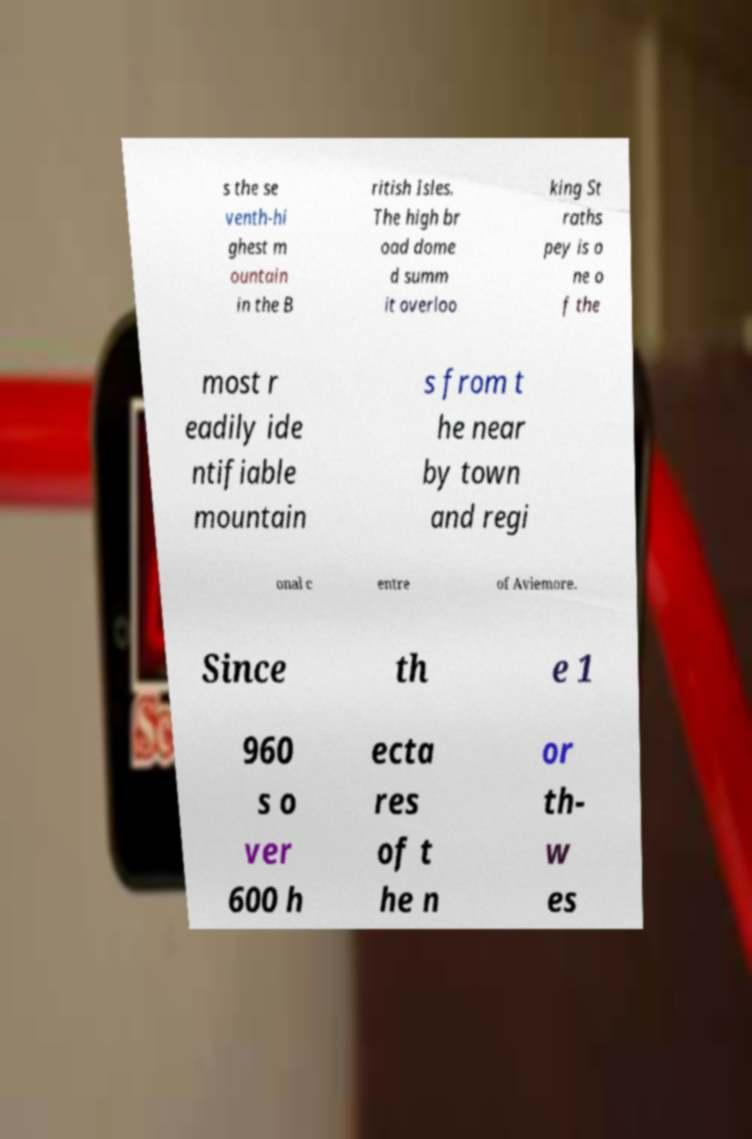Could you assist in decoding the text presented in this image and type it out clearly? s the se venth-hi ghest m ountain in the B ritish Isles. The high br oad dome d summ it overloo king St raths pey is o ne o f the most r eadily ide ntifiable mountain s from t he near by town and regi onal c entre of Aviemore. Since th e 1 960 s o ver 600 h ecta res of t he n or th- w es 